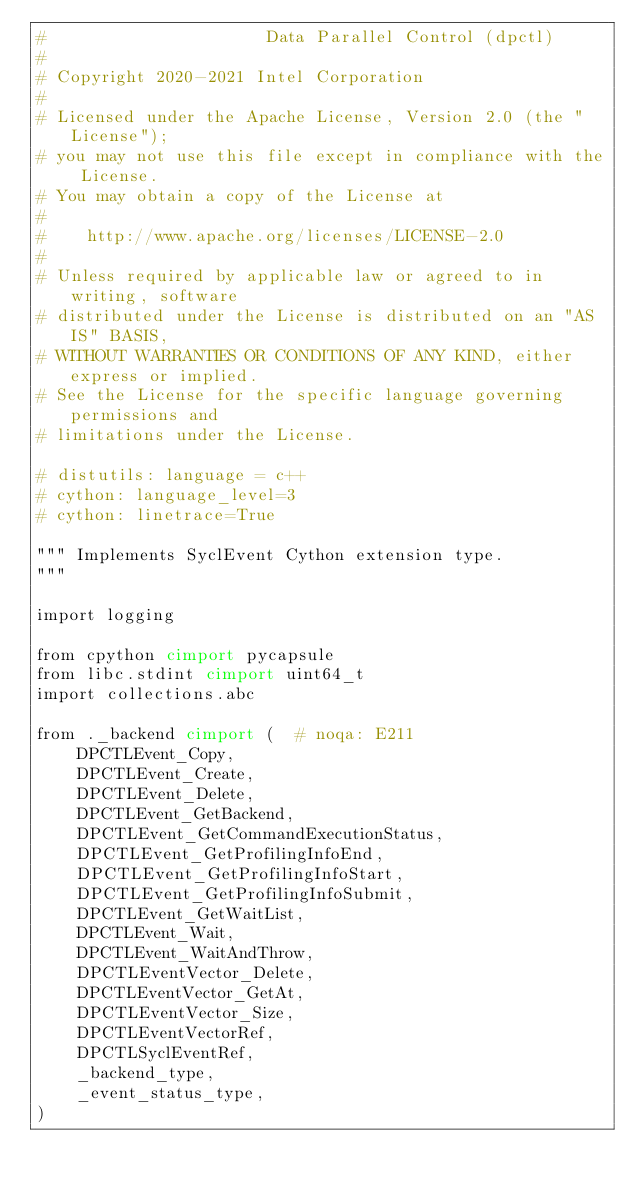<code> <loc_0><loc_0><loc_500><loc_500><_Cython_>#                      Data Parallel Control (dpctl)
#
# Copyright 2020-2021 Intel Corporation
#
# Licensed under the Apache License, Version 2.0 (the "License");
# you may not use this file except in compliance with the License.
# You may obtain a copy of the License at
#
#    http://www.apache.org/licenses/LICENSE-2.0
#
# Unless required by applicable law or agreed to in writing, software
# distributed under the License is distributed on an "AS IS" BASIS,
# WITHOUT WARRANTIES OR CONDITIONS OF ANY KIND, either express or implied.
# See the License for the specific language governing permissions and
# limitations under the License.

# distutils: language = c++
# cython: language_level=3
# cython: linetrace=True

""" Implements SyclEvent Cython extension type.
"""

import logging

from cpython cimport pycapsule
from libc.stdint cimport uint64_t
import collections.abc

from ._backend cimport (  # noqa: E211
    DPCTLEvent_Copy,
    DPCTLEvent_Create,
    DPCTLEvent_Delete,
    DPCTLEvent_GetBackend,
    DPCTLEvent_GetCommandExecutionStatus,
    DPCTLEvent_GetProfilingInfoEnd,
    DPCTLEvent_GetProfilingInfoStart,
    DPCTLEvent_GetProfilingInfoSubmit,
    DPCTLEvent_GetWaitList,
    DPCTLEvent_Wait,
    DPCTLEvent_WaitAndThrow,
    DPCTLEventVector_Delete,
    DPCTLEventVector_GetAt,
    DPCTLEventVector_Size,
    DPCTLEventVectorRef,
    DPCTLSyclEventRef,
    _backend_type,
    _event_status_type,
)
</code> 